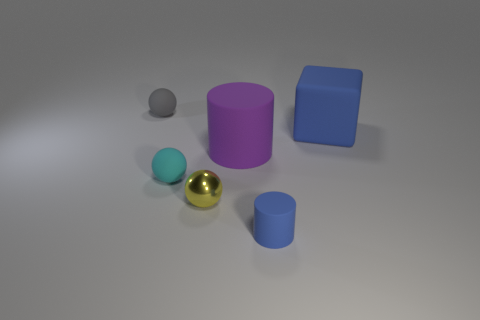Are there any other things that have the same material as the small yellow sphere?
Ensure brevity in your answer.  No. What number of things are small rubber things to the right of the cyan matte object or large matte things?
Offer a terse response. 3. There is a tiny ball in front of the rubber ball in front of the ball behind the big purple object; what is it made of?
Provide a succinct answer. Metal. Are there more large purple matte cylinders in front of the big rubber cylinder than tiny cyan things that are behind the small gray matte sphere?
Provide a short and direct response. No. How many cylinders are tiny cyan rubber objects or purple things?
Give a very brief answer. 1. There is a large matte thing left of the blue thing that is right of the small blue matte cylinder; what number of purple rubber cylinders are behind it?
Keep it short and to the point. 0. There is a object that is the same color as the matte cube; what is it made of?
Your answer should be very brief. Rubber. Are there more tiny cyan matte objects than cylinders?
Provide a short and direct response. No. Do the blue block and the gray object have the same size?
Your response must be concise. No. How many objects are tiny cylinders or big blocks?
Your answer should be very brief. 2. 